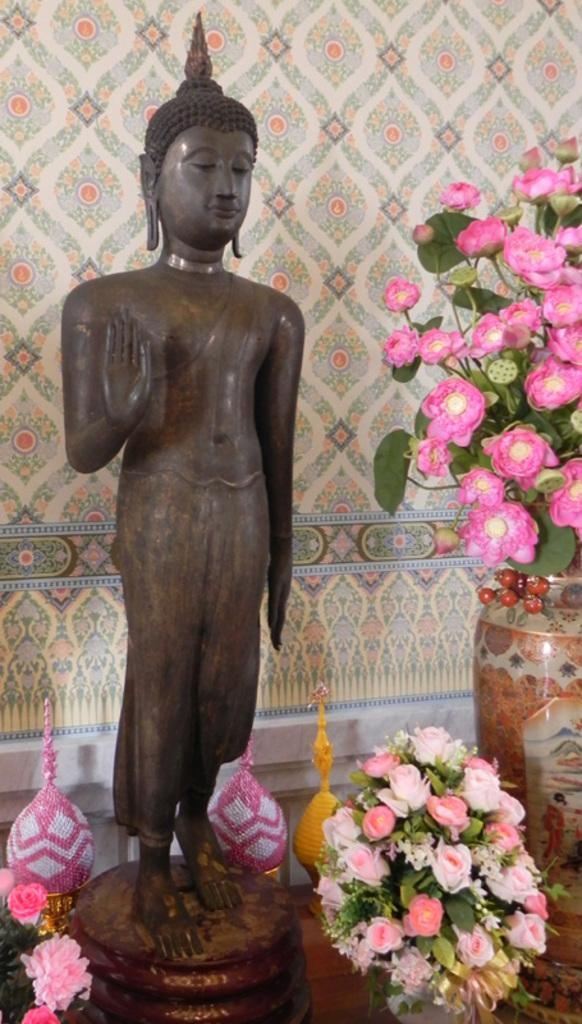What is the main subject in the image? There is a statue in the image. Where is the statue located? The statue is placed on a table. What other objects can be seen in the image? There are pots and flowers visible in the image. What can be seen in the background of the image? There is a wall visible in the background of the image. In which direction is the statue facing in the image? The provided facts do not mention the direction the statue is facing, so we cannot determine that information from the image. 